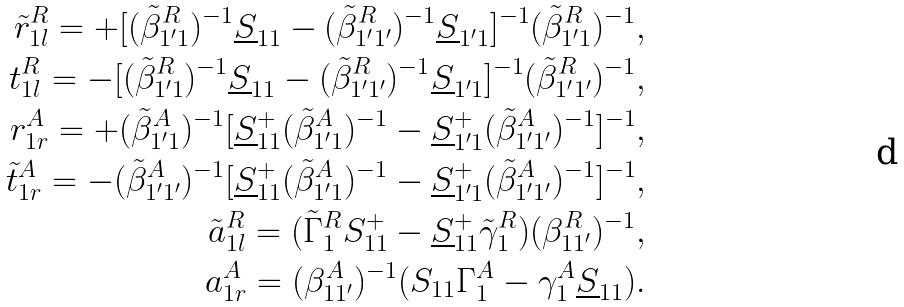Convert formula to latex. <formula><loc_0><loc_0><loc_500><loc_500>\tilde { r } _ { 1 l } ^ { R } = + [ ( \tilde { \beta } _ { 1 ^ { \prime } 1 } ^ { R } ) ^ { - 1 } \underline { S } _ { 1 1 } - ( \tilde { \beta } _ { 1 ^ { \prime } 1 ^ { \prime } } ^ { R } ) ^ { - 1 } \underline { S } _ { 1 ^ { \prime } 1 } ] ^ { - 1 } ( \tilde { \beta } _ { 1 ^ { \prime } 1 } ^ { R } ) ^ { - 1 } , \\ t _ { 1 l } ^ { R } = - [ ( \tilde { \beta } _ { 1 ^ { \prime } 1 } ^ { R } ) ^ { - 1 } \underline { S } _ { 1 1 } - ( \tilde { \beta } _ { 1 ^ { \prime } 1 ^ { \prime } } ^ { R } ) ^ { - 1 } \underline { S } _ { 1 ^ { \prime } 1 } ] ^ { - 1 } ( \tilde { \beta } _ { 1 ^ { \prime } 1 ^ { \prime } } ^ { R } ) ^ { - 1 } , \\ r _ { 1 r } ^ { A } = + ( \tilde { \beta } _ { 1 ^ { \prime } 1 } ^ { A } ) ^ { - 1 } [ \underline { S } _ { 1 1 } ^ { + } ( \tilde { \beta } _ { 1 ^ { \prime } 1 } ^ { A } ) ^ { - 1 } - \underline { S } _ { 1 ^ { \prime } 1 } ^ { + } ( \tilde { \beta } _ { 1 ^ { \prime } 1 ^ { \prime } } ^ { A } ) ^ { - 1 } ] ^ { - 1 } , \\ \tilde { t } _ { 1 r } ^ { A } = - ( \tilde { \beta } _ { 1 ^ { \prime } 1 ^ { \prime } } ^ { A } ) ^ { - 1 } [ \underline { S } _ { 1 1 } ^ { + } ( \tilde { \beta } _ { 1 ^ { \prime } 1 } ^ { A } ) ^ { - 1 } - \underline { S } _ { 1 ^ { \prime } 1 } ^ { + } ( \tilde { \beta } _ { 1 ^ { \prime } 1 ^ { \prime } } ^ { A } ) ^ { - 1 } ] ^ { - 1 } , \\ \tilde { a } _ { 1 l } ^ { R } = ( \tilde { \Gamma } _ { 1 } ^ { R } S _ { 1 1 } ^ { + } - \underline { S } _ { 1 1 } ^ { + } \tilde { \gamma } _ { 1 } ^ { R } ) ( \beta _ { 1 1 ^ { \prime } } ^ { R } ) ^ { - 1 } , \\ a _ { 1 r } ^ { A } = ( \beta _ { 1 1 ^ { \prime } } ^ { A } ) ^ { - 1 } ( S _ { 1 1 } \Gamma _ { 1 } ^ { A } - \gamma _ { 1 } ^ { A } \underline { S } _ { 1 1 } ) .</formula> 